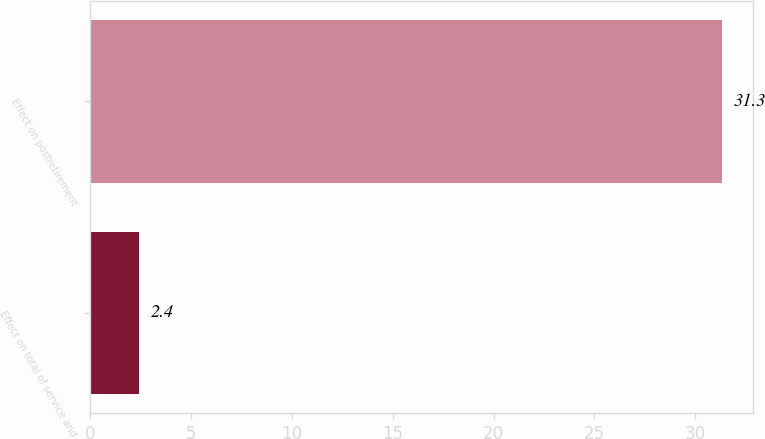<chart> <loc_0><loc_0><loc_500><loc_500><bar_chart><fcel>Effect on total of service and<fcel>Effect on postretirement<nl><fcel>2.4<fcel>31.3<nl></chart> 